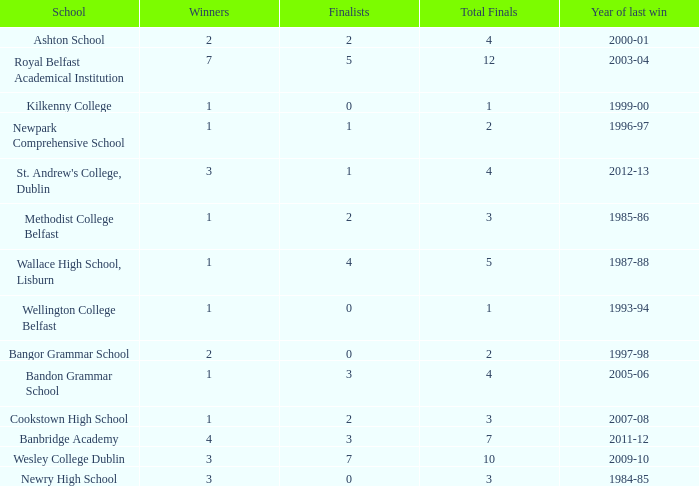Could you parse the entire table? {'header': ['School', 'Winners', 'Finalists', 'Total Finals', 'Year of last win'], 'rows': [['Ashton School', '2', '2', '4', '2000-01'], ['Royal Belfast Academical Institution', '7', '5', '12', '2003-04'], ['Kilkenny College', '1', '0', '1', '1999-00'], ['Newpark Comprehensive School', '1', '1', '2', '1996-97'], ["St. Andrew's College, Dublin", '3', '1', '4', '2012-13'], ['Methodist College Belfast', '1', '2', '3', '1985-86'], ['Wallace High School, Lisburn', '1', '4', '5', '1987-88'], ['Wellington College Belfast', '1', '0', '1', '1993-94'], ['Bangor Grammar School', '2', '0', '2', '1997-98'], ['Bandon Grammar School', '1', '3', '4', '2005-06'], ['Cookstown High School', '1', '2', '3', '2007-08'], ['Banbridge Academy', '4', '3', '7', '2011-12'], ['Wesley College Dublin', '3', '7', '10', '2009-10'], ['Newry High School', '3', '0', '3', '1984-85']]} In what year was the total finals at 10? 2009-10. 